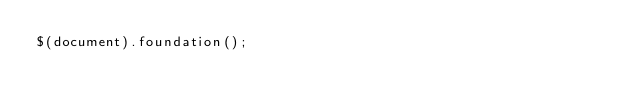<code> <loc_0><loc_0><loc_500><loc_500><_JavaScript_>$(document).foundation();
</code> 